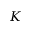Convert formula to latex. <formula><loc_0><loc_0><loc_500><loc_500>K</formula> 